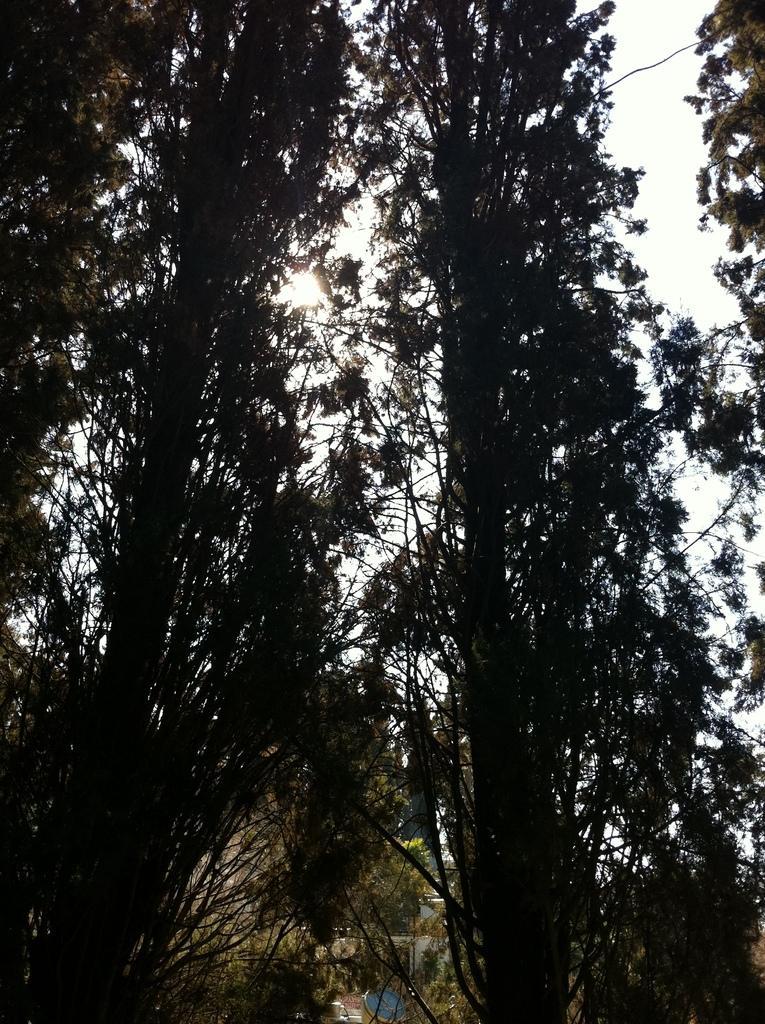How would you summarize this image in a sentence or two? In this picture we can see trees and some objects and in the background we can see the sky. 